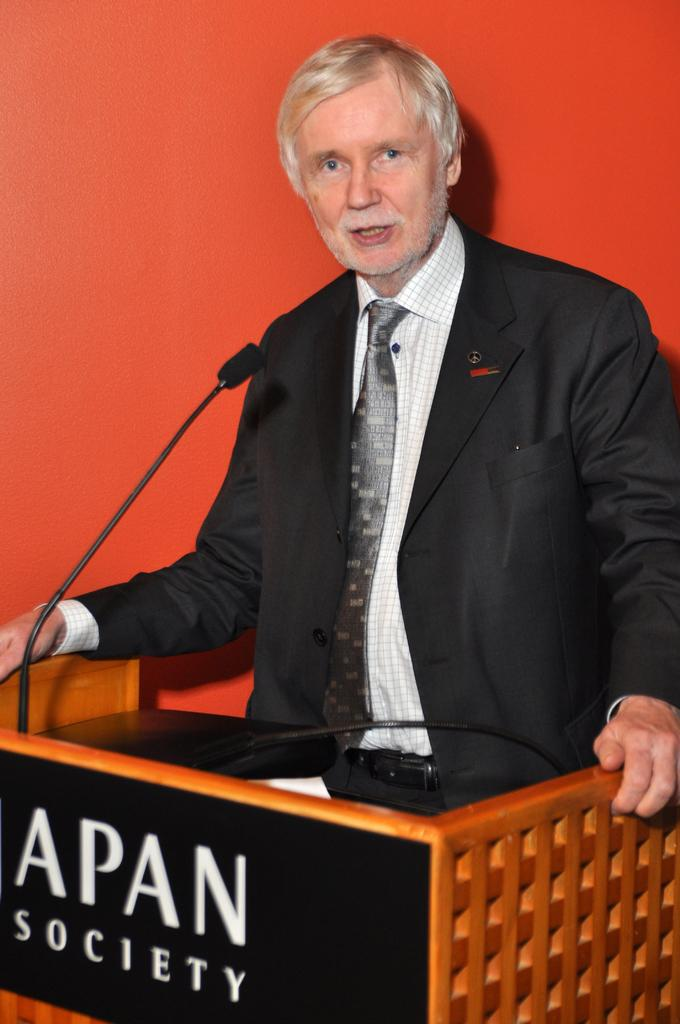What is the main subject in the foreground of the image? There is a man in the foreground of the image. What is the man wearing? The man is wearing a black coat. Where is the man standing in relation to the podium? The man is standing near a podium. What is on the podium? There is a microphone on the podium. What color is the background of the image? The background of the image is red in color. What type of horn can be seen on the man's head in the image? There is no horn present on the man's head in the image. 